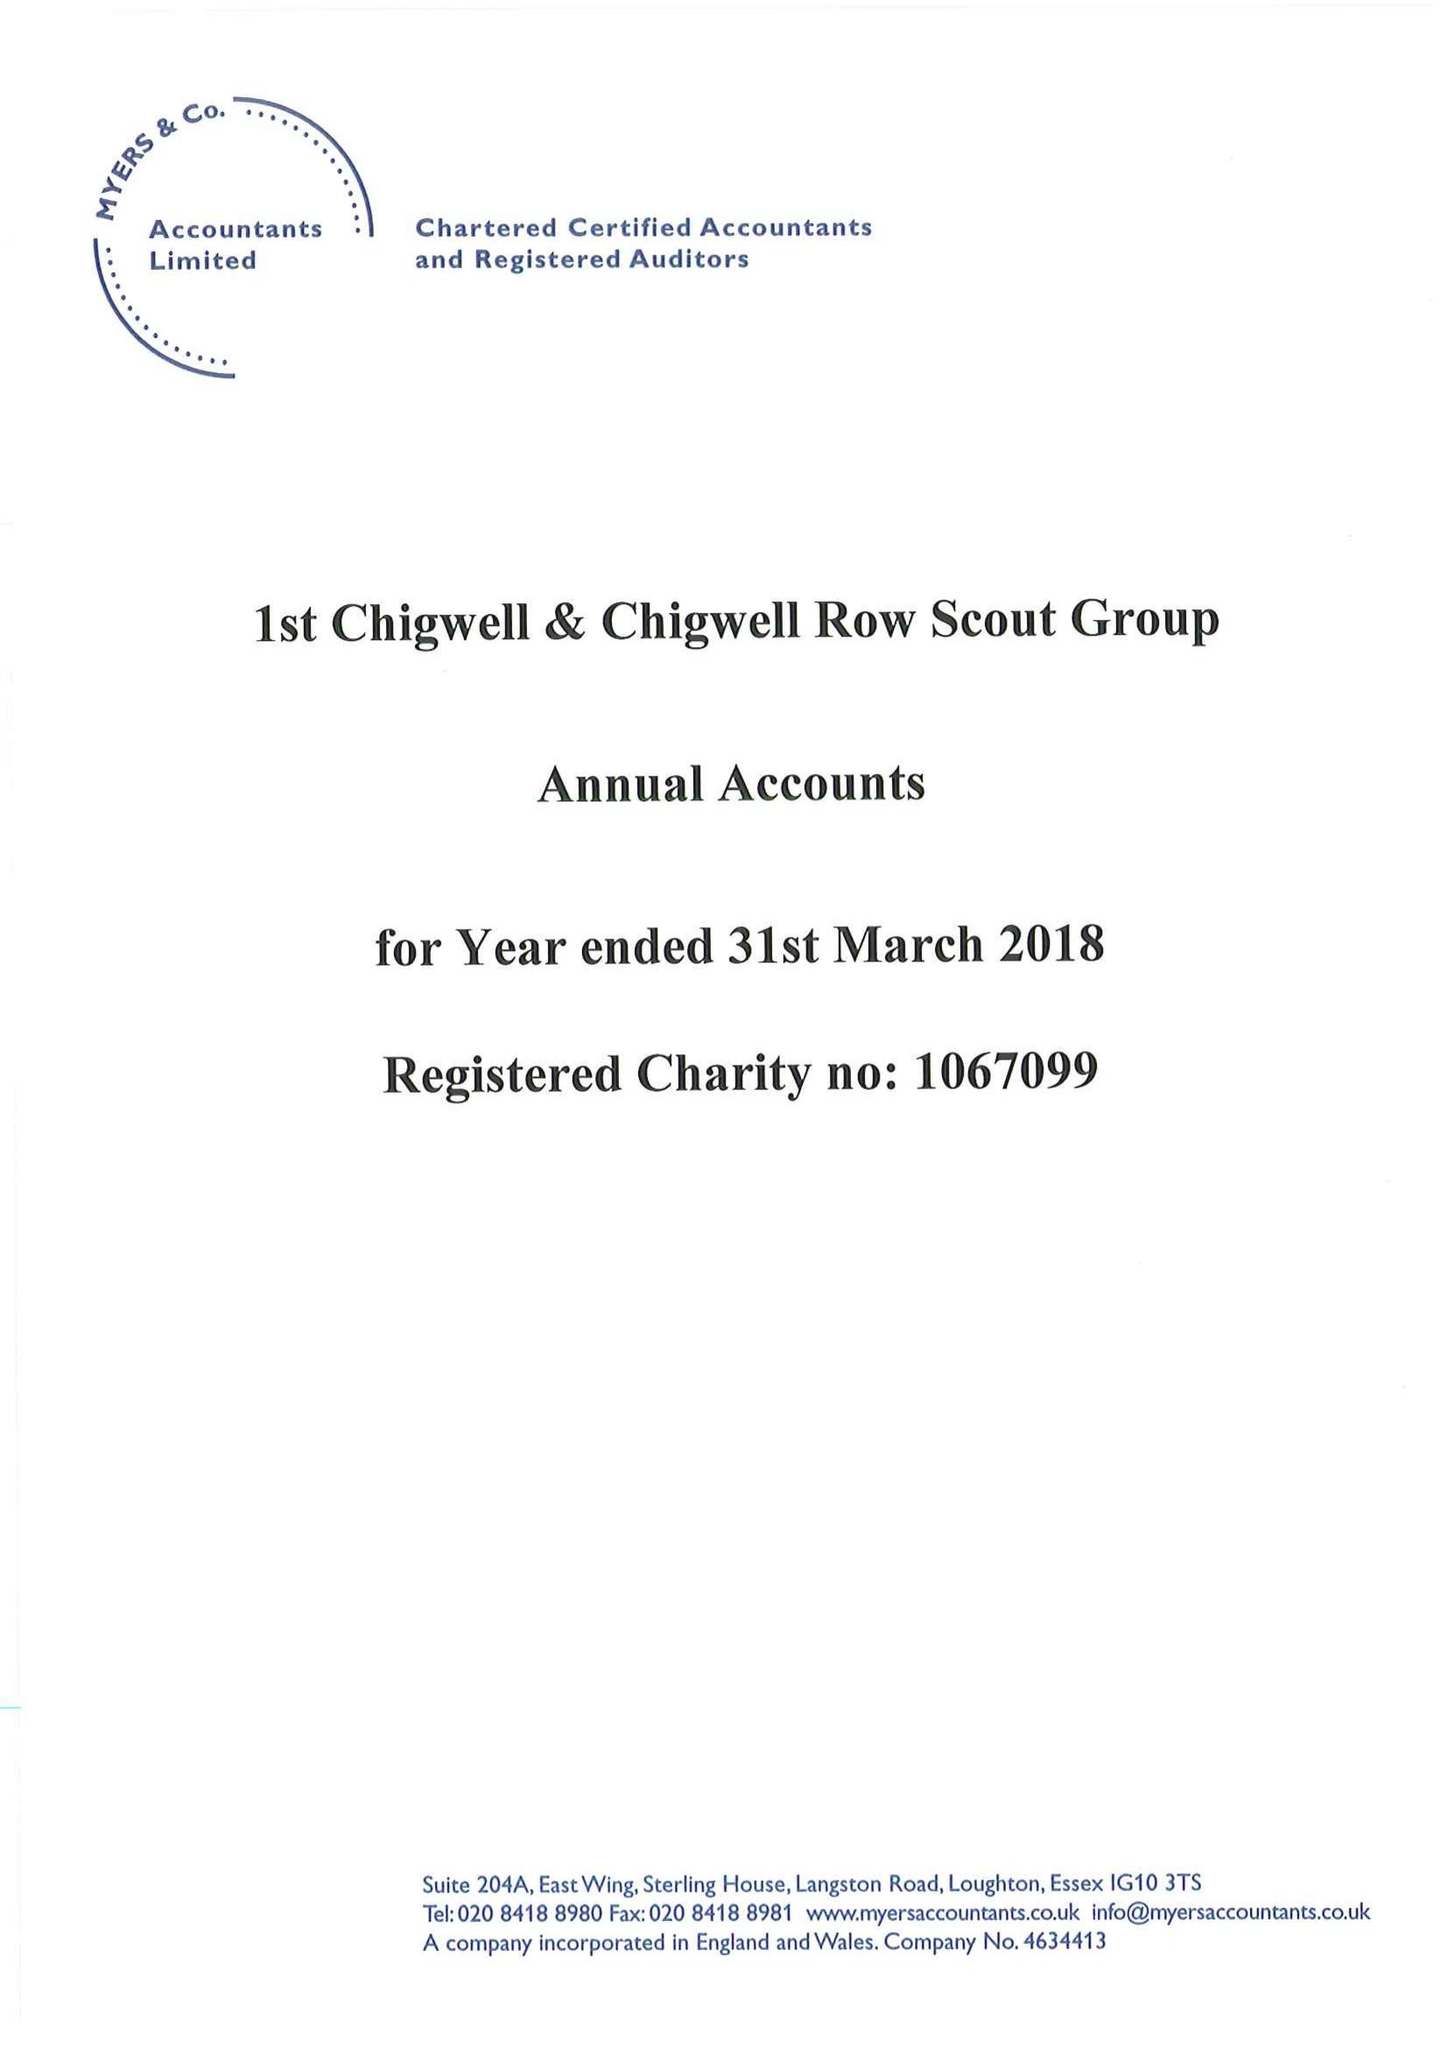What is the value for the address__postcode?
Answer the question using a single word or phrase. None 